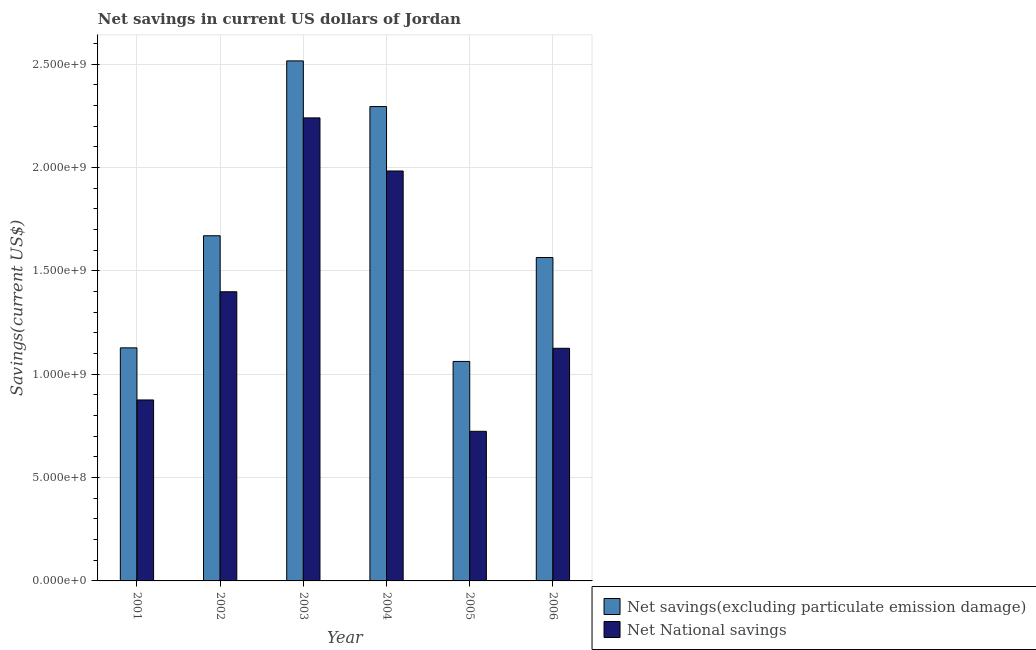How many different coloured bars are there?
Offer a terse response. 2. How many groups of bars are there?
Make the answer very short. 6. Are the number of bars per tick equal to the number of legend labels?
Your response must be concise. Yes. Are the number of bars on each tick of the X-axis equal?
Provide a short and direct response. Yes. How many bars are there on the 5th tick from the left?
Make the answer very short. 2. How many bars are there on the 5th tick from the right?
Make the answer very short. 2. In how many cases, is the number of bars for a given year not equal to the number of legend labels?
Offer a terse response. 0. What is the net savings(excluding particulate emission damage) in 2006?
Keep it short and to the point. 1.56e+09. Across all years, what is the maximum net savings(excluding particulate emission damage)?
Your answer should be compact. 2.52e+09. Across all years, what is the minimum net savings(excluding particulate emission damage)?
Give a very brief answer. 1.06e+09. In which year was the net national savings minimum?
Your answer should be compact. 2005. What is the total net national savings in the graph?
Offer a very short reply. 8.34e+09. What is the difference between the net savings(excluding particulate emission damage) in 2002 and that in 2003?
Make the answer very short. -8.46e+08. What is the difference between the net savings(excluding particulate emission damage) in 2005 and the net national savings in 2003?
Offer a very short reply. -1.45e+09. What is the average net savings(excluding particulate emission damage) per year?
Ensure brevity in your answer.  1.71e+09. In how many years, is the net national savings greater than 1900000000 US$?
Offer a very short reply. 2. What is the ratio of the net national savings in 2004 to that in 2005?
Give a very brief answer. 2.74. Is the net national savings in 2004 less than that in 2006?
Offer a terse response. No. What is the difference between the highest and the second highest net national savings?
Keep it short and to the point. 2.57e+08. What is the difference between the highest and the lowest net national savings?
Ensure brevity in your answer.  1.52e+09. In how many years, is the net national savings greater than the average net national savings taken over all years?
Offer a very short reply. 3. Is the sum of the net savings(excluding particulate emission damage) in 2002 and 2006 greater than the maximum net national savings across all years?
Provide a short and direct response. Yes. What does the 2nd bar from the left in 2004 represents?
Make the answer very short. Net National savings. What does the 2nd bar from the right in 2001 represents?
Your response must be concise. Net savings(excluding particulate emission damage). How many bars are there?
Make the answer very short. 12. Are all the bars in the graph horizontal?
Keep it short and to the point. No. How many years are there in the graph?
Make the answer very short. 6. What is the difference between two consecutive major ticks on the Y-axis?
Your answer should be compact. 5.00e+08. Are the values on the major ticks of Y-axis written in scientific E-notation?
Provide a short and direct response. Yes. Does the graph contain grids?
Make the answer very short. Yes. Where does the legend appear in the graph?
Offer a very short reply. Bottom right. How are the legend labels stacked?
Offer a very short reply. Vertical. What is the title of the graph?
Your response must be concise. Net savings in current US dollars of Jordan. Does "Lowest 20% of population" appear as one of the legend labels in the graph?
Offer a very short reply. No. What is the label or title of the Y-axis?
Your answer should be compact. Savings(current US$). What is the Savings(current US$) in Net savings(excluding particulate emission damage) in 2001?
Your answer should be compact. 1.13e+09. What is the Savings(current US$) in Net National savings in 2001?
Provide a succinct answer. 8.75e+08. What is the Savings(current US$) of Net savings(excluding particulate emission damage) in 2002?
Give a very brief answer. 1.67e+09. What is the Savings(current US$) of Net National savings in 2002?
Provide a succinct answer. 1.40e+09. What is the Savings(current US$) in Net savings(excluding particulate emission damage) in 2003?
Make the answer very short. 2.52e+09. What is the Savings(current US$) in Net National savings in 2003?
Ensure brevity in your answer.  2.24e+09. What is the Savings(current US$) in Net savings(excluding particulate emission damage) in 2004?
Offer a terse response. 2.29e+09. What is the Savings(current US$) of Net National savings in 2004?
Your response must be concise. 1.98e+09. What is the Savings(current US$) of Net savings(excluding particulate emission damage) in 2005?
Provide a succinct answer. 1.06e+09. What is the Savings(current US$) in Net National savings in 2005?
Your answer should be compact. 7.24e+08. What is the Savings(current US$) of Net savings(excluding particulate emission damage) in 2006?
Provide a short and direct response. 1.56e+09. What is the Savings(current US$) of Net National savings in 2006?
Give a very brief answer. 1.13e+09. Across all years, what is the maximum Savings(current US$) of Net savings(excluding particulate emission damage)?
Ensure brevity in your answer.  2.52e+09. Across all years, what is the maximum Savings(current US$) in Net National savings?
Ensure brevity in your answer.  2.24e+09. Across all years, what is the minimum Savings(current US$) in Net savings(excluding particulate emission damage)?
Provide a succinct answer. 1.06e+09. Across all years, what is the minimum Savings(current US$) in Net National savings?
Ensure brevity in your answer.  7.24e+08. What is the total Savings(current US$) in Net savings(excluding particulate emission damage) in the graph?
Your answer should be compact. 1.02e+1. What is the total Savings(current US$) of Net National savings in the graph?
Offer a terse response. 8.34e+09. What is the difference between the Savings(current US$) of Net savings(excluding particulate emission damage) in 2001 and that in 2002?
Provide a short and direct response. -5.42e+08. What is the difference between the Savings(current US$) in Net National savings in 2001 and that in 2002?
Provide a short and direct response. -5.23e+08. What is the difference between the Savings(current US$) of Net savings(excluding particulate emission damage) in 2001 and that in 2003?
Keep it short and to the point. -1.39e+09. What is the difference between the Savings(current US$) of Net National savings in 2001 and that in 2003?
Offer a terse response. -1.36e+09. What is the difference between the Savings(current US$) of Net savings(excluding particulate emission damage) in 2001 and that in 2004?
Your answer should be compact. -1.17e+09. What is the difference between the Savings(current US$) in Net National savings in 2001 and that in 2004?
Provide a short and direct response. -1.11e+09. What is the difference between the Savings(current US$) in Net savings(excluding particulate emission damage) in 2001 and that in 2005?
Your answer should be very brief. 6.57e+07. What is the difference between the Savings(current US$) in Net National savings in 2001 and that in 2005?
Keep it short and to the point. 1.52e+08. What is the difference between the Savings(current US$) of Net savings(excluding particulate emission damage) in 2001 and that in 2006?
Offer a very short reply. -4.37e+08. What is the difference between the Savings(current US$) of Net National savings in 2001 and that in 2006?
Your response must be concise. -2.50e+08. What is the difference between the Savings(current US$) of Net savings(excluding particulate emission damage) in 2002 and that in 2003?
Offer a very short reply. -8.46e+08. What is the difference between the Savings(current US$) of Net National savings in 2002 and that in 2003?
Keep it short and to the point. -8.41e+08. What is the difference between the Savings(current US$) of Net savings(excluding particulate emission damage) in 2002 and that in 2004?
Your response must be concise. -6.25e+08. What is the difference between the Savings(current US$) of Net National savings in 2002 and that in 2004?
Provide a succinct answer. -5.84e+08. What is the difference between the Savings(current US$) of Net savings(excluding particulate emission damage) in 2002 and that in 2005?
Provide a short and direct response. 6.08e+08. What is the difference between the Savings(current US$) of Net National savings in 2002 and that in 2005?
Make the answer very short. 6.75e+08. What is the difference between the Savings(current US$) of Net savings(excluding particulate emission damage) in 2002 and that in 2006?
Offer a very short reply. 1.05e+08. What is the difference between the Savings(current US$) of Net National savings in 2002 and that in 2006?
Make the answer very short. 2.73e+08. What is the difference between the Savings(current US$) of Net savings(excluding particulate emission damage) in 2003 and that in 2004?
Make the answer very short. 2.21e+08. What is the difference between the Savings(current US$) of Net National savings in 2003 and that in 2004?
Ensure brevity in your answer.  2.57e+08. What is the difference between the Savings(current US$) in Net savings(excluding particulate emission damage) in 2003 and that in 2005?
Offer a terse response. 1.45e+09. What is the difference between the Savings(current US$) in Net National savings in 2003 and that in 2005?
Offer a terse response. 1.52e+09. What is the difference between the Savings(current US$) of Net savings(excluding particulate emission damage) in 2003 and that in 2006?
Your answer should be very brief. 9.51e+08. What is the difference between the Savings(current US$) in Net National savings in 2003 and that in 2006?
Give a very brief answer. 1.11e+09. What is the difference between the Savings(current US$) in Net savings(excluding particulate emission damage) in 2004 and that in 2005?
Keep it short and to the point. 1.23e+09. What is the difference between the Savings(current US$) in Net National savings in 2004 and that in 2005?
Give a very brief answer. 1.26e+09. What is the difference between the Savings(current US$) in Net savings(excluding particulate emission damage) in 2004 and that in 2006?
Your response must be concise. 7.30e+08. What is the difference between the Savings(current US$) of Net National savings in 2004 and that in 2006?
Offer a terse response. 8.58e+08. What is the difference between the Savings(current US$) in Net savings(excluding particulate emission damage) in 2005 and that in 2006?
Make the answer very short. -5.03e+08. What is the difference between the Savings(current US$) of Net National savings in 2005 and that in 2006?
Provide a succinct answer. -4.02e+08. What is the difference between the Savings(current US$) of Net savings(excluding particulate emission damage) in 2001 and the Savings(current US$) of Net National savings in 2002?
Ensure brevity in your answer.  -2.71e+08. What is the difference between the Savings(current US$) in Net savings(excluding particulate emission damage) in 2001 and the Savings(current US$) in Net National savings in 2003?
Keep it short and to the point. -1.11e+09. What is the difference between the Savings(current US$) in Net savings(excluding particulate emission damage) in 2001 and the Savings(current US$) in Net National savings in 2004?
Ensure brevity in your answer.  -8.55e+08. What is the difference between the Savings(current US$) in Net savings(excluding particulate emission damage) in 2001 and the Savings(current US$) in Net National savings in 2005?
Provide a short and direct response. 4.04e+08. What is the difference between the Savings(current US$) of Net savings(excluding particulate emission damage) in 2001 and the Savings(current US$) of Net National savings in 2006?
Make the answer very short. 2.11e+06. What is the difference between the Savings(current US$) of Net savings(excluding particulate emission damage) in 2002 and the Savings(current US$) of Net National savings in 2003?
Offer a terse response. -5.70e+08. What is the difference between the Savings(current US$) of Net savings(excluding particulate emission damage) in 2002 and the Savings(current US$) of Net National savings in 2004?
Your answer should be compact. -3.13e+08. What is the difference between the Savings(current US$) of Net savings(excluding particulate emission damage) in 2002 and the Savings(current US$) of Net National savings in 2005?
Provide a short and direct response. 9.46e+08. What is the difference between the Savings(current US$) of Net savings(excluding particulate emission damage) in 2002 and the Savings(current US$) of Net National savings in 2006?
Make the answer very short. 5.44e+08. What is the difference between the Savings(current US$) of Net savings(excluding particulate emission damage) in 2003 and the Savings(current US$) of Net National savings in 2004?
Provide a short and direct response. 5.33e+08. What is the difference between the Savings(current US$) in Net savings(excluding particulate emission damage) in 2003 and the Savings(current US$) in Net National savings in 2005?
Ensure brevity in your answer.  1.79e+09. What is the difference between the Savings(current US$) in Net savings(excluding particulate emission damage) in 2003 and the Savings(current US$) in Net National savings in 2006?
Provide a succinct answer. 1.39e+09. What is the difference between the Savings(current US$) in Net savings(excluding particulate emission damage) in 2004 and the Savings(current US$) in Net National savings in 2005?
Provide a short and direct response. 1.57e+09. What is the difference between the Savings(current US$) of Net savings(excluding particulate emission damage) in 2004 and the Savings(current US$) of Net National savings in 2006?
Offer a terse response. 1.17e+09. What is the difference between the Savings(current US$) of Net savings(excluding particulate emission damage) in 2005 and the Savings(current US$) of Net National savings in 2006?
Your response must be concise. -6.36e+07. What is the average Savings(current US$) of Net savings(excluding particulate emission damage) per year?
Offer a very short reply. 1.71e+09. What is the average Savings(current US$) of Net National savings per year?
Offer a very short reply. 1.39e+09. In the year 2001, what is the difference between the Savings(current US$) in Net savings(excluding particulate emission damage) and Savings(current US$) in Net National savings?
Keep it short and to the point. 2.52e+08. In the year 2002, what is the difference between the Savings(current US$) in Net savings(excluding particulate emission damage) and Savings(current US$) in Net National savings?
Provide a succinct answer. 2.71e+08. In the year 2003, what is the difference between the Savings(current US$) of Net savings(excluding particulate emission damage) and Savings(current US$) of Net National savings?
Provide a short and direct response. 2.76e+08. In the year 2004, what is the difference between the Savings(current US$) in Net savings(excluding particulate emission damage) and Savings(current US$) in Net National savings?
Provide a succinct answer. 3.12e+08. In the year 2005, what is the difference between the Savings(current US$) of Net savings(excluding particulate emission damage) and Savings(current US$) of Net National savings?
Make the answer very short. 3.38e+08. In the year 2006, what is the difference between the Savings(current US$) in Net savings(excluding particulate emission damage) and Savings(current US$) in Net National savings?
Ensure brevity in your answer.  4.39e+08. What is the ratio of the Savings(current US$) in Net savings(excluding particulate emission damage) in 2001 to that in 2002?
Keep it short and to the point. 0.68. What is the ratio of the Savings(current US$) in Net National savings in 2001 to that in 2002?
Provide a succinct answer. 0.63. What is the ratio of the Savings(current US$) in Net savings(excluding particulate emission damage) in 2001 to that in 2003?
Your answer should be very brief. 0.45. What is the ratio of the Savings(current US$) in Net National savings in 2001 to that in 2003?
Provide a short and direct response. 0.39. What is the ratio of the Savings(current US$) of Net savings(excluding particulate emission damage) in 2001 to that in 2004?
Your answer should be compact. 0.49. What is the ratio of the Savings(current US$) in Net National savings in 2001 to that in 2004?
Your answer should be compact. 0.44. What is the ratio of the Savings(current US$) in Net savings(excluding particulate emission damage) in 2001 to that in 2005?
Your answer should be very brief. 1.06. What is the ratio of the Savings(current US$) of Net National savings in 2001 to that in 2005?
Provide a short and direct response. 1.21. What is the ratio of the Savings(current US$) in Net savings(excluding particulate emission damage) in 2001 to that in 2006?
Your answer should be very brief. 0.72. What is the ratio of the Savings(current US$) of Net National savings in 2001 to that in 2006?
Ensure brevity in your answer.  0.78. What is the ratio of the Savings(current US$) of Net savings(excluding particulate emission damage) in 2002 to that in 2003?
Provide a succinct answer. 0.66. What is the ratio of the Savings(current US$) of Net National savings in 2002 to that in 2003?
Your answer should be compact. 0.62. What is the ratio of the Savings(current US$) of Net savings(excluding particulate emission damage) in 2002 to that in 2004?
Offer a very short reply. 0.73. What is the ratio of the Savings(current US$) of Net National savings in 2002 to that in 2004?
Ensure brevity in your answer.  0.71. What is the ratio of the Savings(current US$) in Net savings(excluding particulate emission damage) in 2002 to that in 2005?
Your response must be concise. 1.57. What is the ratio of the Savings(current US$) in Net National savings in 2002 to that in 2005?
Keep it short and to the point. 1.93. What is the ratio of the Savings(current US$) of Net savings(excluding particulate emission damage) in 2002 to that in 2006?
Your response must be concise. 1.07. What is the ratio of the Savings(current US$) in Net National savings in 2002 to that in 2006?
Provide a succinct answer. 1.24. What is the ratio of the Savings(current US$) in Net savings(excluding particulate emission damage) in 2003 to that in 2004?
Keep it short and to the point. 1.1. What is the ratio of the Savings(current US$) in Net National savings in 2003 to that in 2004?
Your response must be concise. 1.13. What is the ratio of the Savings(current US$) of Net savings(excluding particulate emission damage) in 2003 to that in 2005?
Offer a terse response. 2.37. What is the ratio of the Savings(current US$) of Net National savings in 2003 to that in 2005?
Your response must be concise. 3.09. What is the ratio of the Savings(current US$) in Net savings(excluding particulate emission damage) in 2003 to that in 2006?
Your response must be concise. 1.61. What is the ratio of the Savings(current US$) in Net National savings in 2003 to that in 2006?
Your answer should be very brief. 1.99. What is the ratio of the Savings(current US$) in Net savings(excluding particulate emission damage) in 2004 to that in 2005?
Provide a short and direct response. 2.16. What is the ratio of the Savings(current US$) of Net National savings in 2004 to that in 2005?
Offer a very short reply. 2.74. What is the ratio of the Savings(current US$) in Net savings(excluding particulate emission damage) in 2004 to that in 2006?
Your answer should be very brief. 1.47. What is the ratio of the Savings(current US$) of Net National savings in 2004 to that in 2006?
Provide a short and direct response. 1.76. What is the ratio of the Savings(current US$) in Net savings(excluding particulate emission damage) in 2005 to that in 2006?
Your answer should be compact. 0.68. What is the ratio of the Savings(current US$) of Net National savings in 2005 to that in 2006?
Offer a very short reply. 0.64. What is the difference between the highest and the second highest Savings(current US$) of Net savings(excluding particulate emission damage)?
Your answer should be very brief. 2.21e+08. What is the difference between the highest and the second highest Savings(current US$) of Net National savings?
Provide a short and direct response. 2.57e+08. What is the difference between the highest and the lowest Savings(current US$) of Net savings(excluding particulate emission damage)?
Provide a short and direct response. 1.45e+09. What is the difference between the highest and the lowest Savings(current US$) of Net National savings?
Make the answer very short. 1.52e+09. 